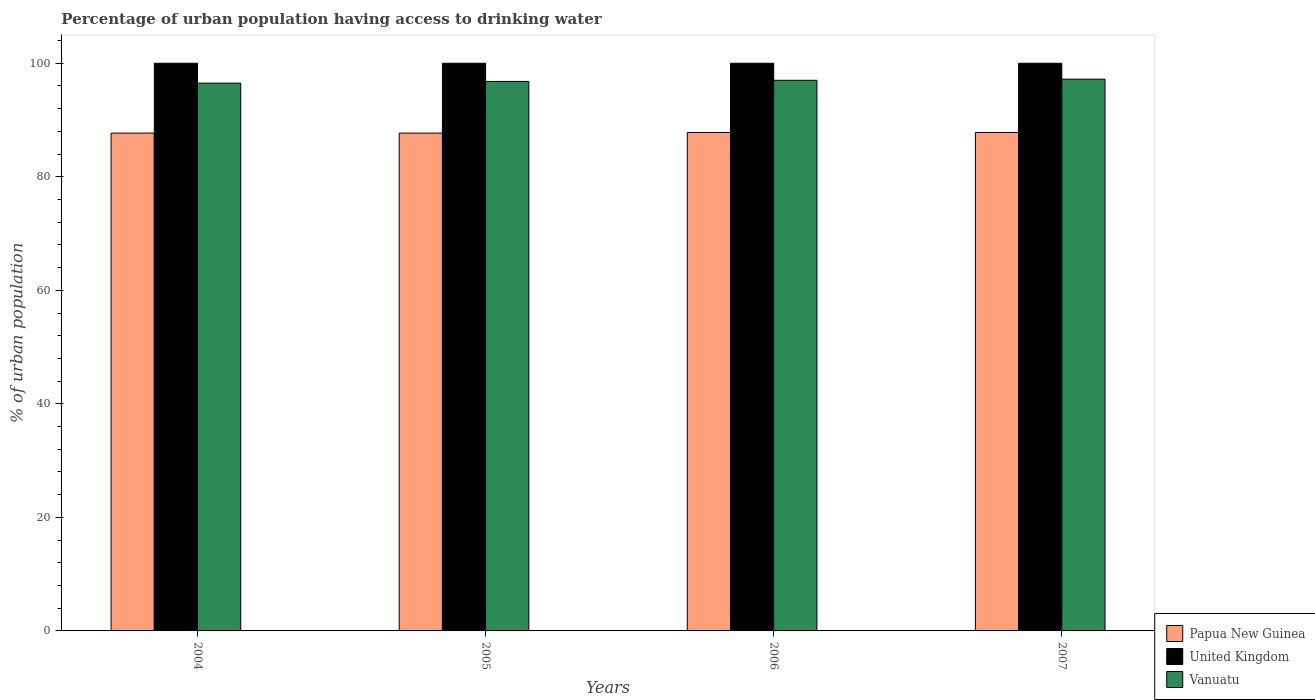Are the number of bars per tick equal to the number of legend labels?
Your response must be concise. Yes. How many bars are there on the 4th tick from the left?
Your response must be concise. 3. What is the percentage of urban population having access to drinking water in United Kingdom in 2006?
Your answer should be very brief. 100. Across all years, what is the maximum percentage of urban population having access to drinking water in Papua New Guinea?
Make the answer very short. 87.8. Across all years, what is the minimum percentage of urban population having access to drinking water in Vanuatu?
Ensure brevity in your answer.  96.5. What is the total percentage of urban population having access to drinking water in Vanuatu in the graph?
Your answer should be very brief. 387.5. What is the difference between the percentage of urban population having access to drinking water in Papua New Guinea in 2006 and that in 2007?
Offer a terse response. 0. What is the difference between the percentage of urban population having access to drinking water in United Kingdom in 2005 and the percentage of urban population having access to drinking water in Papua New Guinea in 2004?
Offer a terse response. 12.3. What is the average percentage of urban population having access to drinking water in United Kingdom per year?
Provide a short and direct response. 100. In the year 2004, what is the difference between the percentage of urban population having access to drinking water in Vanuatu and percentage of urban population having access to drinking water in Papua New Guinea?
Give a very brief answer. 8.8. What is the ratio of the percentage of urban population having access to drinking water in United Kingdom in 2004 to that in 2006?
Provide a succinct answer. 1. What is the difference between the highest and the lowest percentage of urban population having access to drinking water in Papua New Guinea?
Ensure brevity in your answer.  0.1. In how many years, is the percentage of urban population having access to drinking water in United Kingdom greater than the average percentage of urban population having access to drinking water in United Kingdom taken over all years?
Ensure brevity in your answer.  0. Is the sum of the percentage of urban population having access to drinking water in Papua New Guinea in 2006 and 2007 greater than the maximum percentage of urban population having access to drinking water in Vanuatu across all years?
Offer a very short reply. Yes. What does the 3rd bar from the right in 2004 represents?
Your answer should be compact. Papua New Guinea. Is it the case that in every year, the sum of the percentage of urban population having access to drinking water in United Kingdom and percentage of urban population having access to drinking water in Papua New Guinea is greater than the percentage of urban population having access to drinking water in Vanuatu?
Offer a terse response. Yes. How many bars are there?
Offer a terse response. 12. Are all the bars in the graph horizontal?
Make the answer very short. No. How many years are there in the graph?
Your response must be concise. 4. What is the difference between two consecutive major ticks on the Y-axis?
Provide a short and direct response. 20. Does the graph contain grids?
Make the answer very short. No. Where does the legend appear in the graph?
Make the answer very short. Bottom right. How are the legend labels stacked?
Your answer should be very brief. Vertical. What is the title of the graph?
Provide a succinct answer. Percentage of urban population having access to drinking water. What is the label or title of the X-axis?
Ensure brevity in your answer.  Years. What is the label or title of the Y-axis?
Offer a terse response. % of urban population. What is the % of urban population in Papua New Guinea in 2004?
Provide a succinct answer. 87.7. What is the % of urban population in United Kingdom in 2004?
Your answer should be compact. 100. What is the % of urban population in Vanuatu in 2004?
Give a very brief answer. 96.5. What is the % of urban population of Papua New Guinea in 2005?
Make the answer very short. 87.7. What is the % of urban population of United Kingdom in 2005?
Keep it short and to the point. 100. What is the % of urban population in Vanuatu in 2005?
Offer a very short reply. 96.8. What is the % of urban population of Papua New Guinea in 2006?
Provide a succinct answer. 87.8. What is the % of urban population in Vanuatu in 2006?
Make the answer very short. 97. What is the % of urban population in Papua New Guinea in 2007?
Make the answer very short. 87.8. What is the % of urban population in United Kingdom in 2007?
Ensure brevity in your answer.  100. What is the % of urban population of Vanuatu in 2007?
Your answer should be compact. 97.2. Across all years, what is the maximum % of urban population in Papua New Guinea?
Offer a terse response. 87.8. Across all years, what is the maximum % of urban population of Vanuatu?
Make the answer very short. 97.2. Across all years, what is the minimum % of urban population in Papua New Guinea?
Provide a succinct answer. 87.7. Across all years, what is the minimum % of urban population of United Kingdom?
Ensure brevity in your answer.  100. Across all years, what is the minimum % of urban population of Vanuatu?
Make the answer very short. 96.5. What is the total % of urban population in Papua New Guinea in the graph?
Provide a short and direct response. 351. What is the total % of urban population of United Kingdom in the graph?
Your answer should be very brief. 400. What is the total % of urban population of Vanuatu in the graph?
Give a very brief answer. 387.5. What is the difference between the % of urban population of United Kingdom in 2004 and that in 2005?
Ensure brevity in your answer.  0. What is the difference between the % of urban population in Vanuatu in 2004 and that in 2005?
Make the answer very short. -0.3. What is the difference between the % of urban population in United Kingdom in 2004 and that in 2006?
Your response must be concise. 0. What is the difference between the % of urban population in Vanuatu in 2004 and that in 2007?
Your answer should be compact. -0.7. What is the difference between the % of urban population of Papua New Guinea in 2005 and that in 2006?
Offer a very short reply. -0.1. What is the difference between the % of urban population in United Kingdom in 2005 and that in 2007?
Your answer should be very brief. 0. What is the difference between the % of urban population of Vanuatu in 2005 and that in 2007?
Make the answer very short. -0.4. What is the difference between the % of urban population of United Kingdom in 2006 and that in 2007?
Offer a terse response. 0. What is the difference between the % of urban population of Papua New Guinea in 2004 and the % of urban population of United Kingdom in 2005?
Ensure brevity in your answer.  -12.3. What is the difference between the % of urban population in Papua New Guinea in 2004 and the % of urban population in United Kingdom in 2006?
Your response must be concise. -12.3. What is the difference between the % of urban population in United Kingdom in 2004 and the % of urban population in Vanuatu in 2007?
Offer a terse response. 2.8. What is the difference between the % of urban population of Papua New Guinea in 2005 and the % of urban population of Vanuatu in 2006?
Offer a terse response. -9.3. What is the difference between the % of urban population of Papua New Guinea in 2005 and the % of urban population of United Kingdom in 2007?
Provide a succinct answer. -12.3. What is the difference between the % of urban population of Papua New Guinea in 2006 and the % of urban population of United Kingdom in 2007?
Make the answer very short. -12.2. What is the difference between the % of urban population in Papua New Guinea in 2006 and the % of urban population in Vanuatu in 2007?
Provide a short and direct response. -9.4. What is the average % of urban population in Papua New Guinea per year?
Give a very brief answer. 87.75. What is the average % of urban population of Vanuatu per year?
Your answer should be compact. 96.88. In the year 2004, what is the difference between the % of urban population in Papua New Guinea and % of urban population in United Kingdom?
Make the answer very short. -12.3. In the year 2004, what is the difference between the % of urban population of Papua New Guinea and % of urban population of Vanuatu?
Your answer should be very brief. -8.8. In the year 2004, what is the difference between the % of urban population of United Kingdom and % of urban population of Vanuatu?
Offer a terse response. 3.5. In the year 2005, what is the difference between the % of urban population in Papua New Guinea and % of urban population in United Kingdom?
Your response must be concise. -12.3. In the year 2005, what is the difference between the % of urban population in Papua New Guinea and % of urban population in Vanuatu?
Give a very brief answer. -9.1. In the year 2005, what is the difference between the % of urban population of United Kingdom and % of urban population of Vanuatu?
Give a very brief answer. 3.2. In the year 2006, what is the difference between the % of urban population in Papua New Guinea and % of urban population in United Kingdom?
Your response must be concise. -12.2. In the year 2007, what is the difference between the % of urban population of Papua New Guinea and % of urban population of United Kingdom?
Your answer should be compact. -12.2. What is the ratio of the % of urban population in United Kingdom in 2004 to that in 2005?
Give a very brief answer. 1. What is the ratio of the % of urban population of Vanuatu in 2004 to that in 2006?
Provide a short and direct response. 0.99. What is the ratio of the % of urban population of Vanuatu in 2004 to that in 2007?
Keep it short and to the point. 0.99. What is the ratio of the % of urban population in Papua New Guinea in 2005 to that in 2007?
Give a very brief answer. 1. What is the ratio of the % of urban population of United Kingdom in 2005 to that in 2007?
Ensure brevity in your answer.  1. What is the ratio of the % of urban population in Vanuatu in 2005 to that in 2007?
Give a very brief answer. 1. What is the difference between the highest and the second highest % of urban population in Papua New Guinea?
Provide a succinct answer. 0. What is the difference between the highest and the second highest % of urban population in United Kingdom?
Provide a succinct answer. 0. What is the difference between the highest and the second highest % of urban population of Vanuatu?
Your answer should be compact. 0.2. What is the difference between the highest and the lowest % of urban population of Papua New Guinea?
Your answer should be compact. 0.1. What is the difference between the highest and the lowest % of urban population of United Kingdom?
Offer a terse response. 0. 